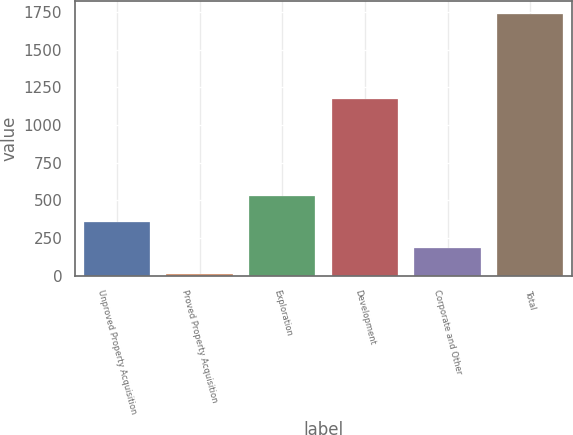Convert chart. <chart><loc_0><loc_0><loc_500><loc_500><bar_chart><fcel>Unproved Property Acquisition<fcel>Proved Property Acquisition<fcel>Exploration<fcel>Development<fcel>Corporate and Other<fcel>Total<nl><fcel>356.6<fcel>11<fcel>529.4<fcel>1175<fcel>183.8<fcel>1739<nl></chart> 